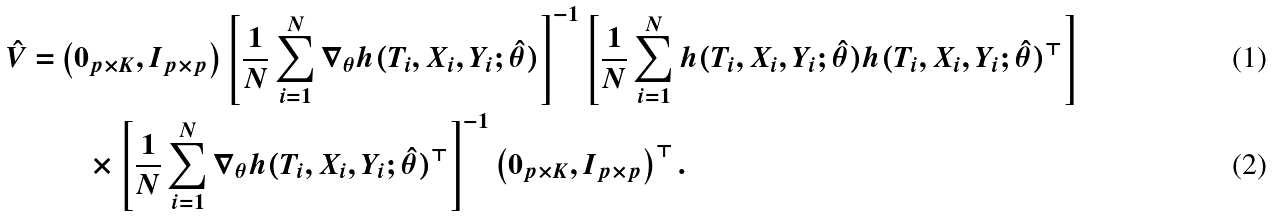Convert formula to latex. <formula><loc_0><loc_0><loc_500><loc_500>\hat { V } = & \left ( 0 _ { p \times K } , I _ { p \times p } \right ) \left [ \frac { 1 } { N } \sum _ { i = 1 } ^ { N } \nabla _ { \theta } h ( T _ { i } , X _ { i } , Y _ { i } ; \hat { \theta } ) \right ] ^ { - 1 } \left [ \frac { 1 } { N } \sum _ { i = 1 } ^ { N } h ( T _ { i } , X _ { i } , Y _ { i } ; \hat { \theta } ) h ( T _ { i } , X _ { i } , Y _ { i } ; \hat { \theta } ) ^ { \top } \right ] \\ & \quad \times \left [ \frac { 1 } { N } \sum _ { i = 1 } ^ { N } \nabla _ { \theta } h ( T _ { i } , X _ { i } , Y _ { i } ; \hat { \theta } ) ^ { \top } \right ] ^ { - 1 } \left ( 0 _ { p \times K } , I _ { p \times p } \right ) ^ { \top } .</formula> 